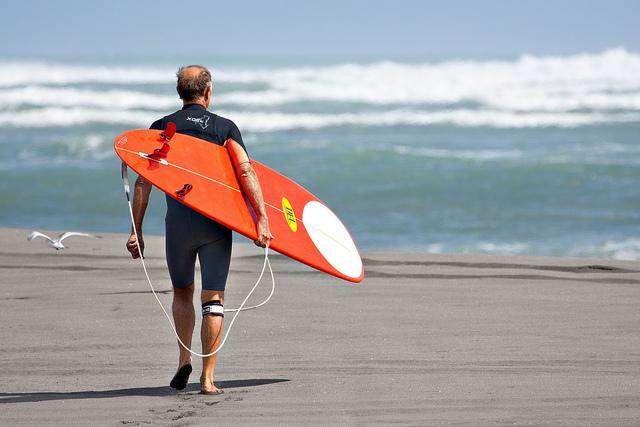What is the cable on the man's leg called? Please explain your reasoning. surfboard leash. The cable is for surfing. 